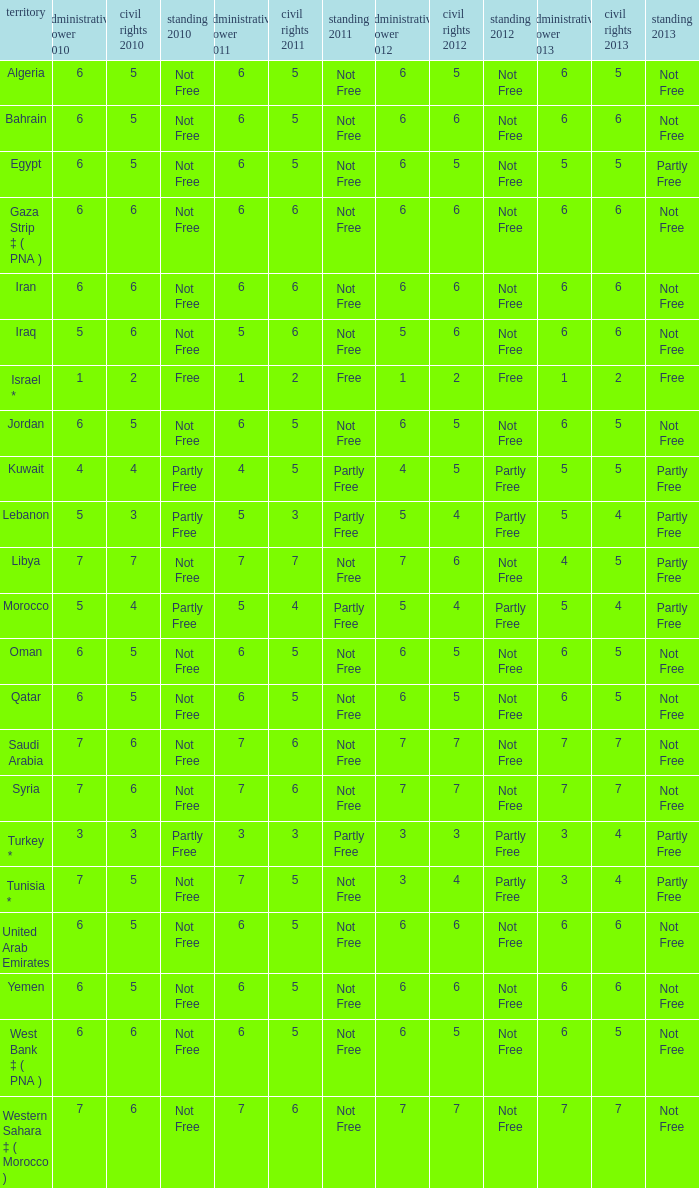What is the average 2012 civil liberties value associated with a 2011 status of not free, political rights 2012 over 6, and political rights 2011 over 7? None. 